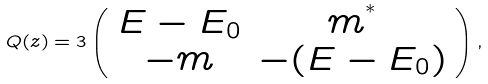<formula> <loc_0><loc_0><loc_500><loc_500>Q ( z ) = 3 \left ( \begin{array} { c c } E - E _ { 0 } & m ^ { ^ { * } } \\ - m & - ( E - E _ { 0 } ) \end{array} \right ) ,</formula> 